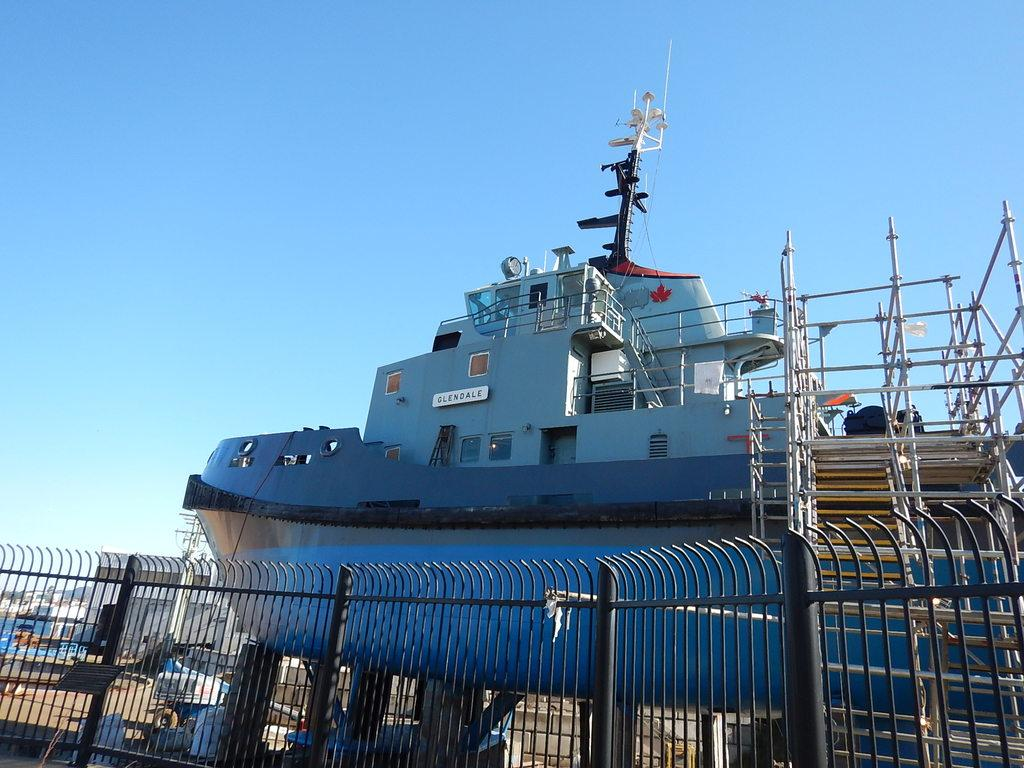What can be seen in the foreground of the picture? There is railing in the foreground of the picture. What is the main subject in the center of the picture? There is a boat in the center of the picture. What other objects are present in the center of the picture? There are vehicles and buildings in the center of the picture. How would you describe the weather in the image? The sky is sunny in the image. Can you see a heart-shaped object on the boat in the image? There is no heart-shaped object present on the boat in the image. Are there any trays visible on the vehicles in the image? There is no mention of trays in the provided facts, and therefore we cannot determine if any are visible on the vehicles. 